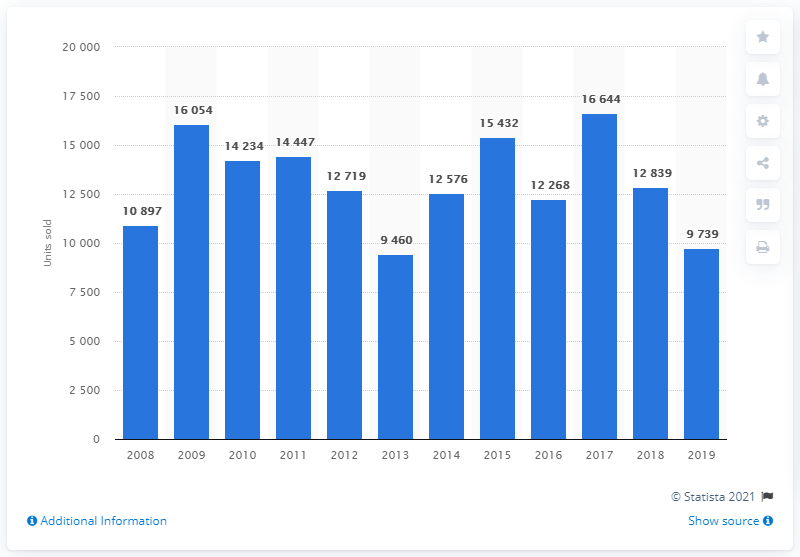Point out several critical features in this image. In the year 2019, a total of 9,739 Ford cars were sold in the Czech Republic. In 2017, a total of 16,644 Ford cars were sold in the Czech Republic. 